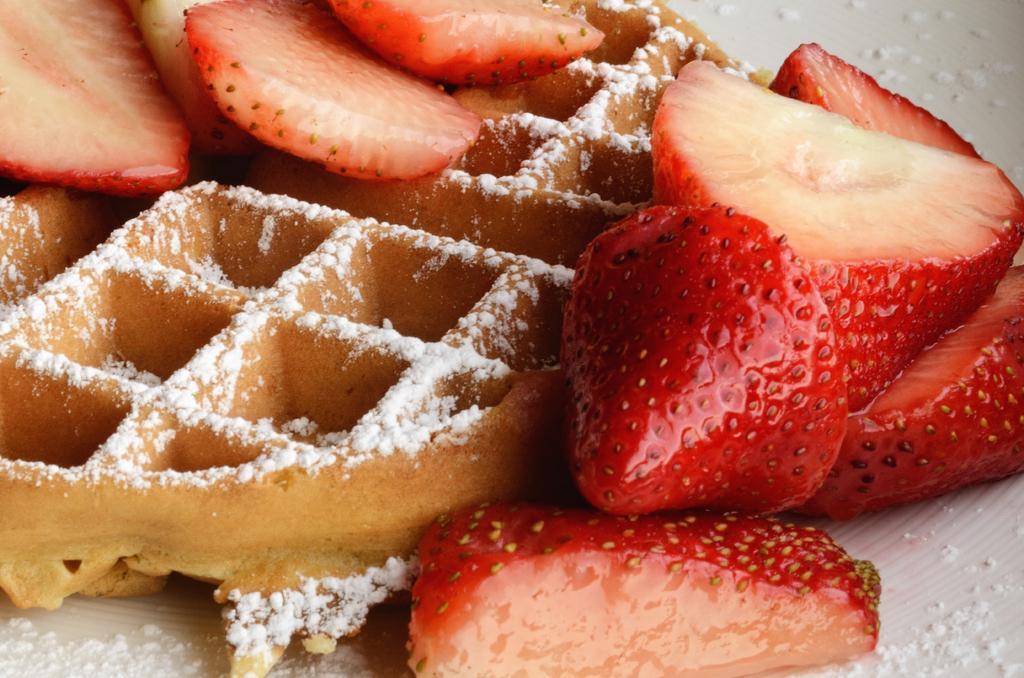Can you describe this image briefly? In the image in the center, we can see one cake. On the cake, we can see strawberry slices and some food item. 